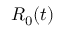Convert formula to latex. <formula><loc_0><loc_0><loc_500><loc_500>R _ { 0 } ( t )</formula> 